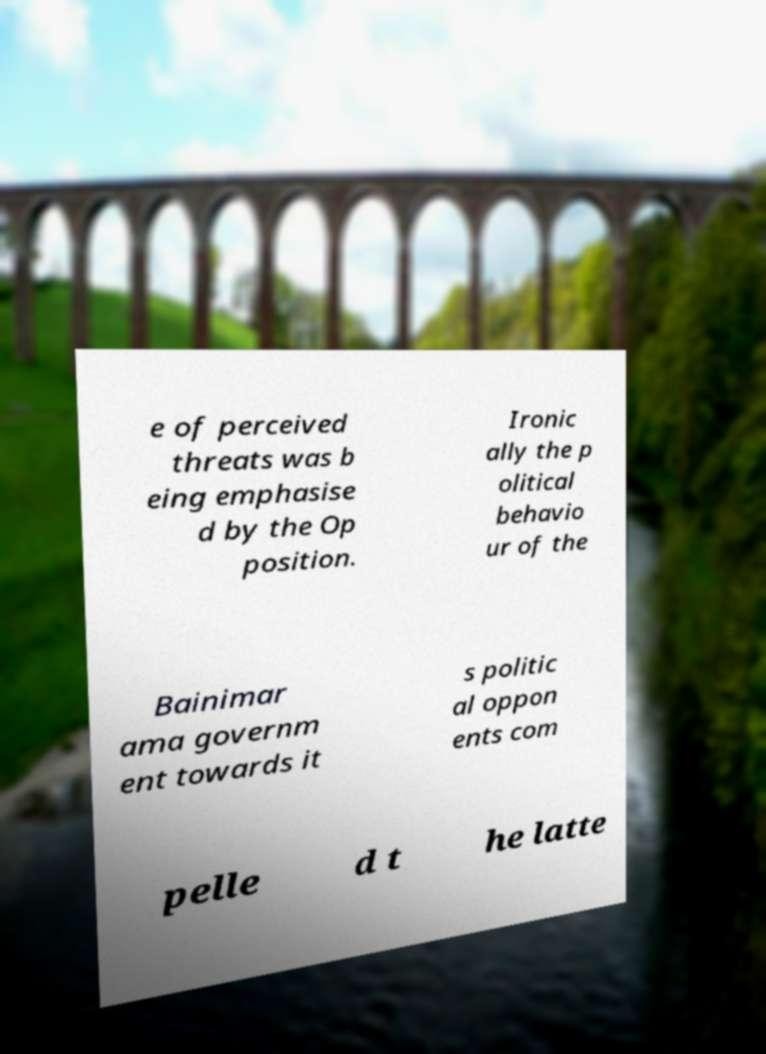For documentation purposes, I need the text within this image transcribed. Could you provide that? e of perceived threats was b eing emphasise d by the Op position. Ironic ally the p olitical behavio ur of the Bainimar ama governm ent towards it s politic al oppon ents com pelle d t he latte 